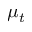Convert formula to latex. <formula><loc_0><loc_0><loc_500><loc_500>\mu _ { t }</formula> 